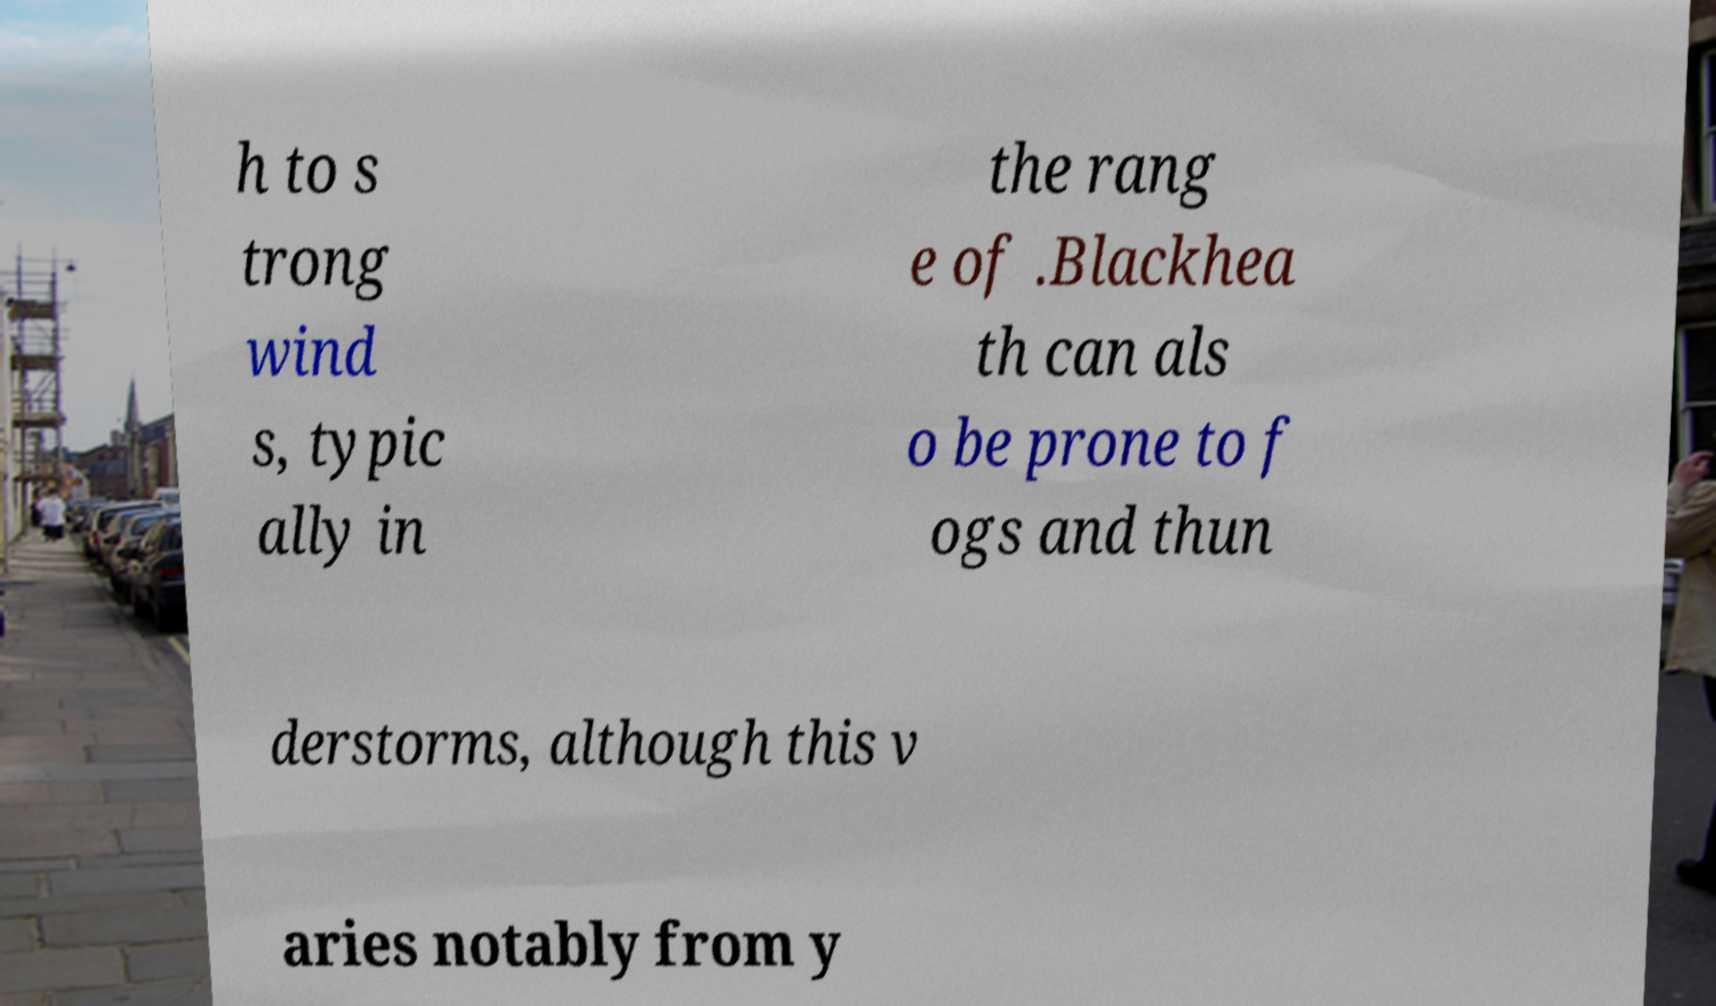What messages or text are displayed in this image? I need them in a readable, typed format. h to s trong wind s, typic ally in the rang e of .Blackhea th can als o be prone to f ogs and thun derstorms, although this v aries notably from y 